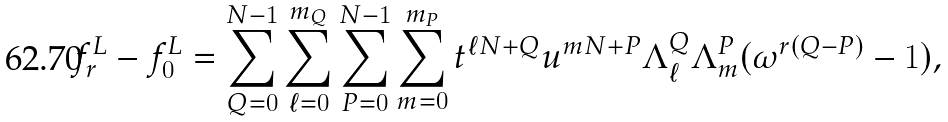<formula> <loc_0><loc_0><loc_500><loc_500>f _ { r } ^ { L } - f _ { 0 } ^ { L } = \sum _ { Q = 0 } ^ { N - 1 } \sum _ { \ell = 0 } ^ { m _ { Q } } \sum _ { P = 0 } ^ { N - 1 } \sum _ { m = 0 } ^ { m _ { P } } t ^ { \ell N + Q } u ^ { m N + P } \Lambda ^ { Q } _ { \ell } \Lambda ^ { P } _ { m } ( \omega ^ { r ( Q - P ) } - 1 ) ,</formula> 